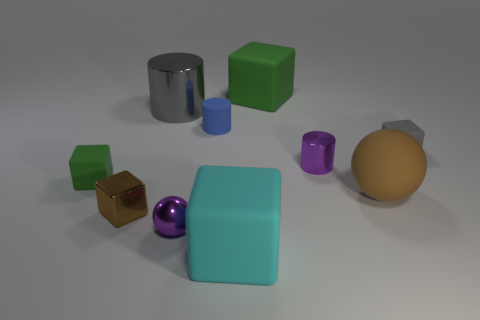There is a cube that is the same color as the big rubber sphere; what is it made of?
Keep it short and to the point. Metal. There is a object that is the same color as the tiny metal block; what is its shape?
Keep it short and to the point. Sphere. How many balls are the same color as the shiny cube?
Offer a terse response. 1. Are there fewer purple spheres than large yellow metal cylinders?
Your answer should be very brief. No. Do the gray cylinder and the small brown object have the same material?
Your answer should be compact. Yes. What number of other objects are there of the same size as the matte cylinder?
Your answer should be compact. 5. What color is the large block that is in front of the green matte thing to the left of the small purple metal ball?
Provide a succinct answer. Cyan. What number of other things are the same shape as the small brown metal object?
Provide a short and direct response. 4. Are there any tiny brown things made of the same material as the tiny purple cylinder?
Your response must be concise. Yes. What material is the gray cylinder that is the same size as the rubber ball?
Offer a terse response. Metal. 